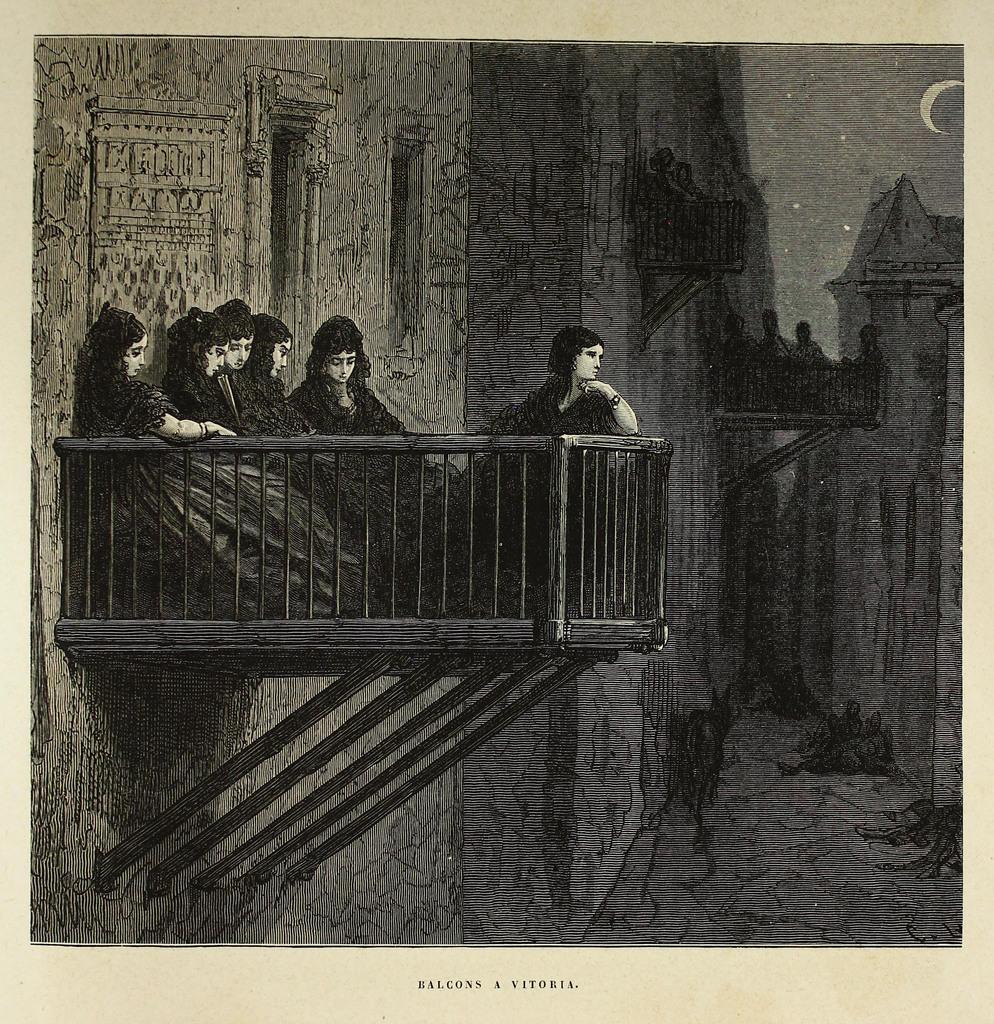Describe this image in one or two sentences. It is a black and white image, on the left side few women are there. On the right there are stars and a moon. 